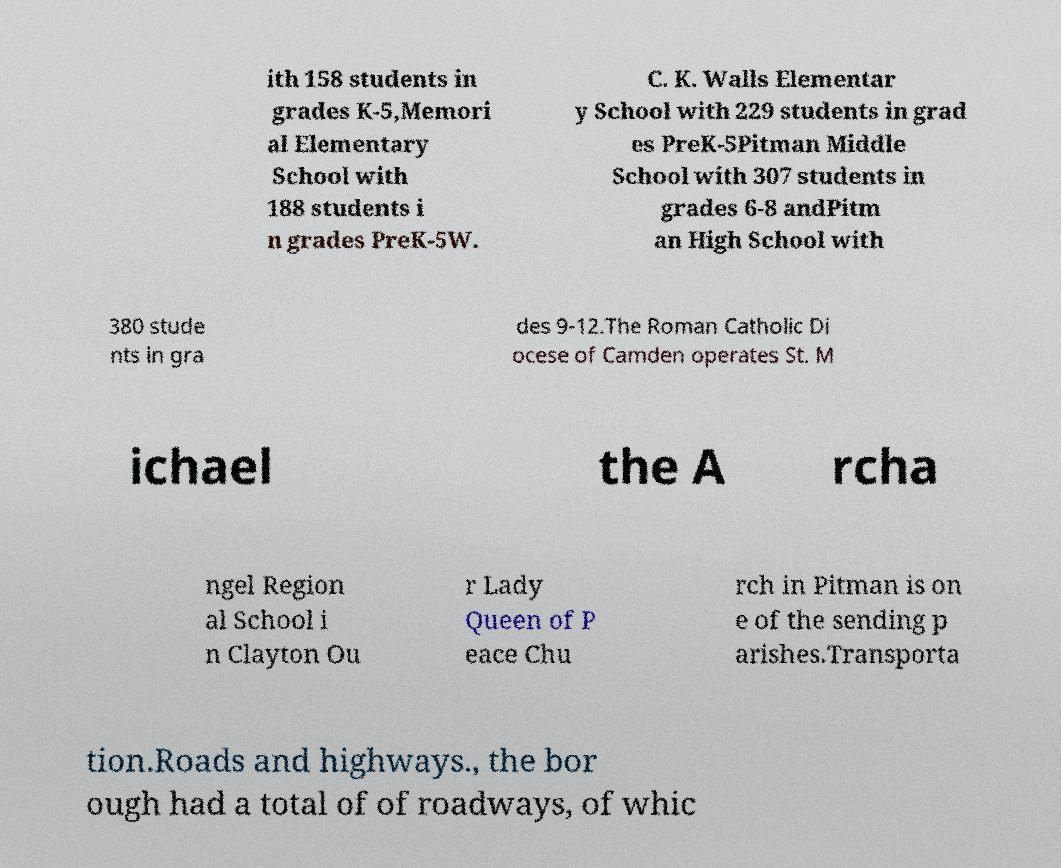I need the written content from this picture converted into text. Can you do that? ith 158 students in grades K-5,Memori al Elementary School with 188 students i n grades PreK-5W. C. K. Walls Elementar y School with 229 students in grad es PreK-5Pitman Middle School with 307 students in grades 6-8 andPitm an High School with 380 stude nts in gra des 9-12.The Roman Catholic Di ocese of Camden operates St. M ichael the A rcha ngel Region al School i n Clayton Ou r Lady Queen of P eace Chu rch in Pitman is on e of the sending p arishes.Transporta tion.Roads and highways., the bor ough had a total of of roadways, of whic 